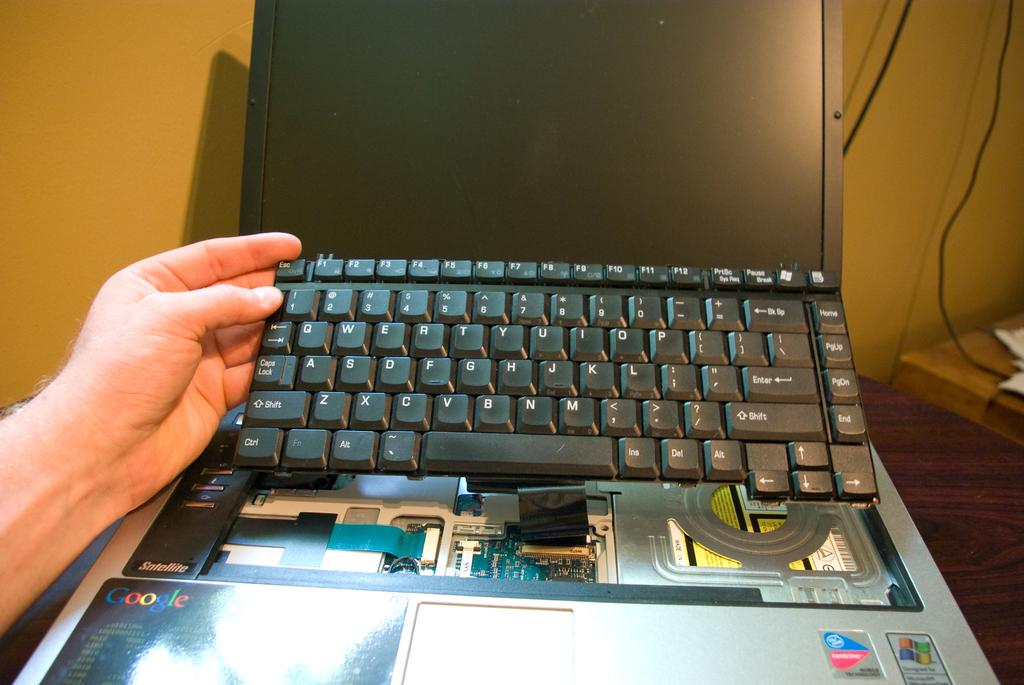<image>
Create a compact narrative representing the image presented. a Centrino powered laptop has the keyboard taken out 